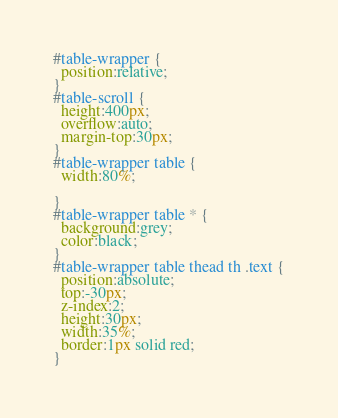<code> <loc_0><loc_0><loc_500><loc_500><_CSS_>#table-wrapper {
  position:relative;
}
#table-scroll {
  height:400px;
  overflow:auto;  
  margin-top:30px;
}
#table-wrapper table {
  width:80%;

}
#table-wrapper table * {
  background:grey;
  color:black;
}
#table-wrapper table thead th .text {
  position:absolute;   
  top:-30px;
  z-index:2;
  height:30px;
  width:35%;
  border:1px solid red;
}</code> 